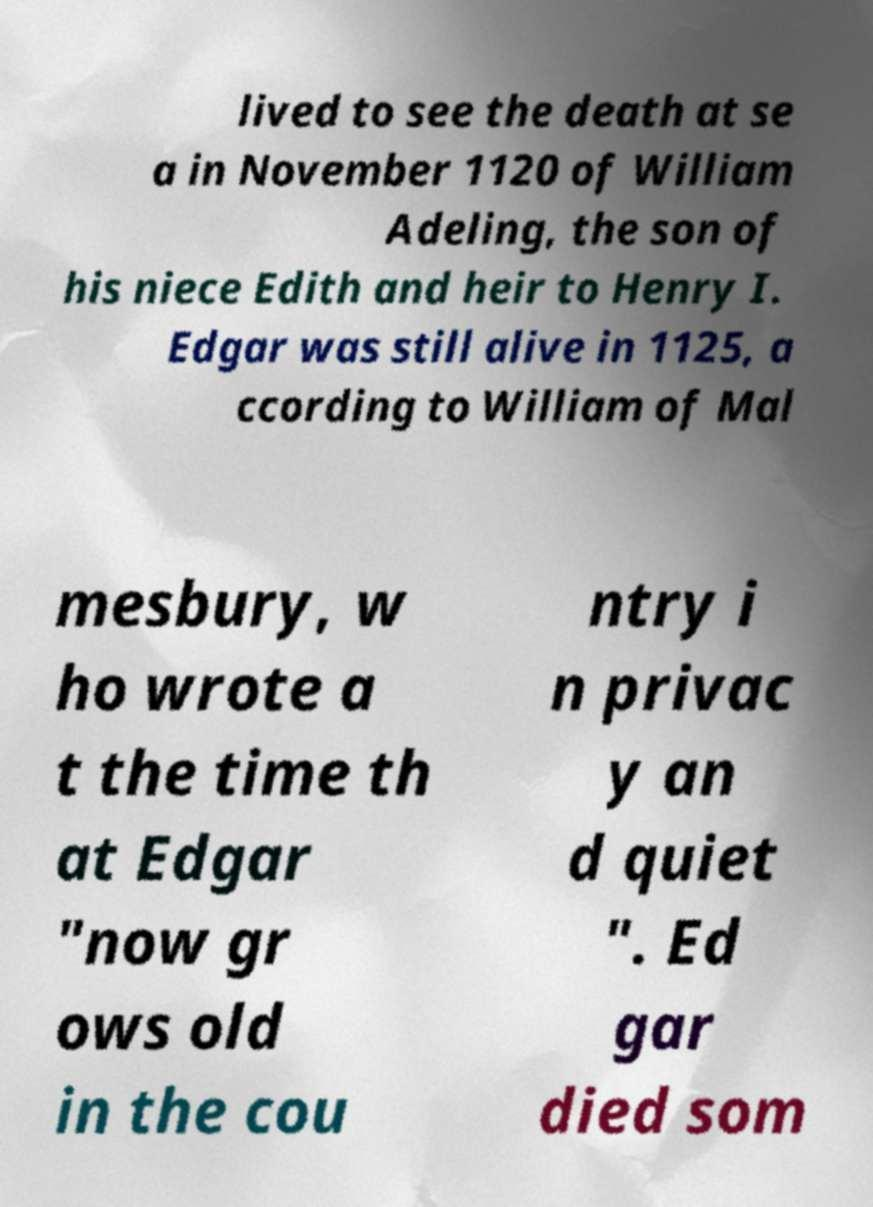Could you extract and type out the text from this image? lived to see the death at se a in November 1120 of William Adeling, the son of his niece Edith and heir to Henry I. Edgar was still alive in 1125, a ccording to William of Mal mesbury, w ho wrote a t the time th at Edgar "now gr ows old in the cou ntry i n privac y an d quiet ". Ed gar died som 